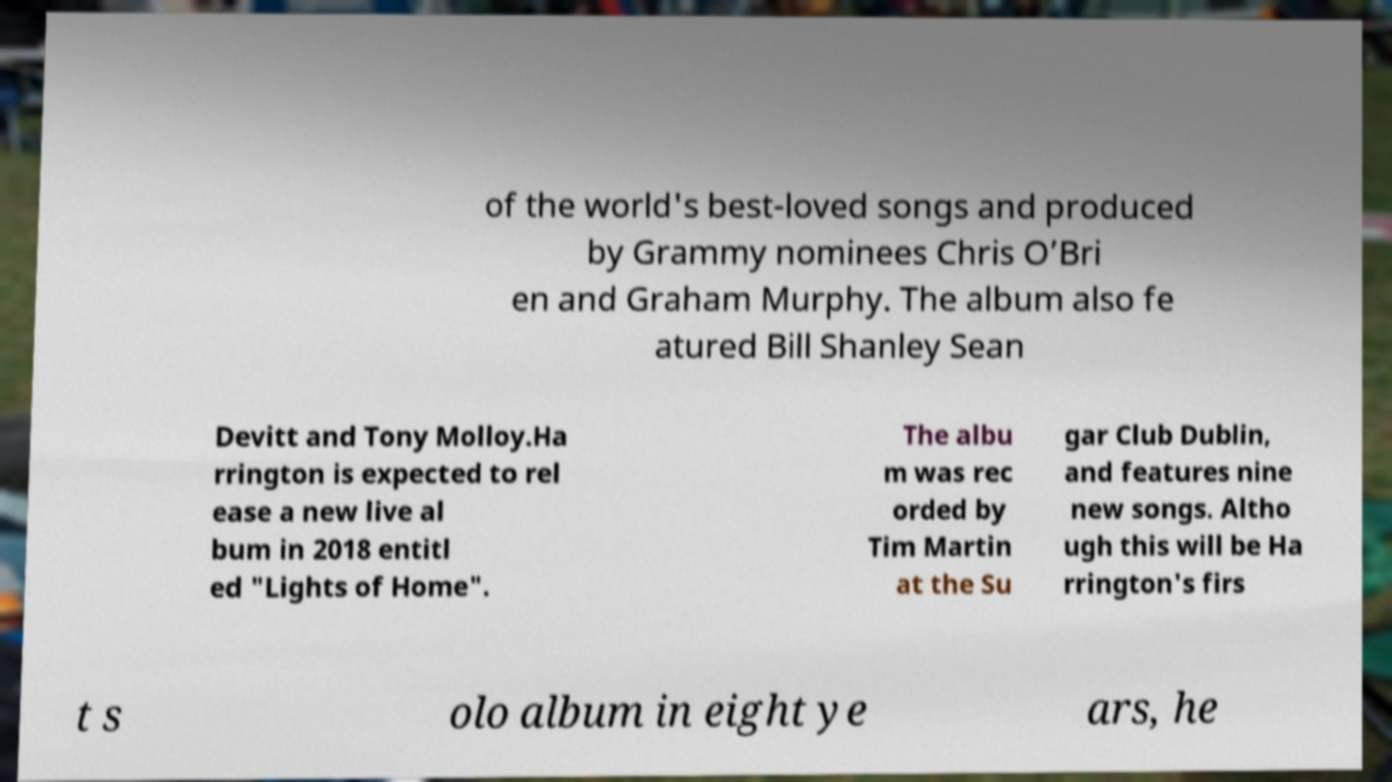Please identify and transcribe the text found in this image. of the world's best-loved songs and produced by Grammy nominees Chris O’Bri en and Graham Murphy. The album also fe atured Bill Shanley Sean Devitt and Tony Molloy.Ha rrington is expected to rel ease a new live al bum in 2018 entitl ed "Lights of Home". The albu m was rec orded by Tim Martin at the Su gar Club Dublin, and features nine new songs. Altho ugh this will be Ha rrington's firs t s olo album in eight ye ars, he 